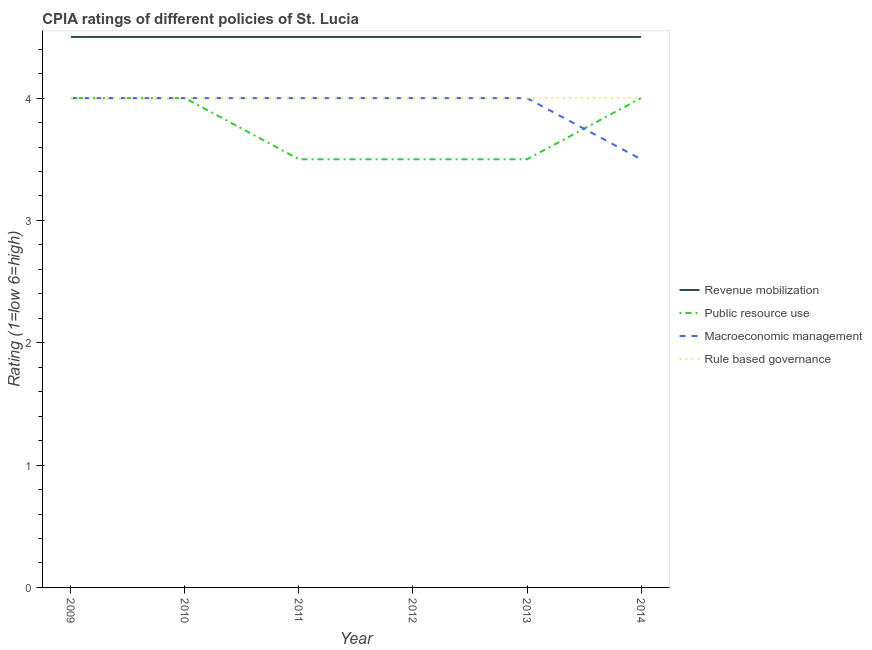Is the number of lines equal to the number of legend labels?
Offer a very short reply. Yes. What is the cpia rating of public resource use in 2011?
Provide a short and direct response. 3.5. Across all years, what is the maximum cpia rating of rule based governance?
Offer a very short reply. 4. Across all years, what is the minimum cpia rating of macroeconomic management?
Your answer should be compact. 3.5. What is the difference between the cpia rating of rule based governance in 2010 and that in 2014?
Offer a terse response. 0. What is the difference between the cpia rating of revenue mobilization in 2014 and the cpia rating of rule based governance in 2012?
Your response must be concise. 0.5. In the year 2011, what is the difference between the cpia rating of macroeconomic management and cpia rating of revenue mobilization?
Provide a succinct answer. -0.5. Is the difference between the cpia rating of macroeconomic management in 2010 and 2012 greater than the difference between the cpia rating of revenue mobilization in 2010 and 2012?
Keep it short and to the point. No. What is the difference between the highest and the lowest cpia rating of revenue mobilization?
Make the answer very short. 0. In how many years, is the cpia rating of rule based governance greater than the average cpia rating of rule based governance taken over all years?
Your response must be concise. 0. Is the sum of the cpia rating of rule based governance in 2009 and 2010 greater than the maximum cpia rating of revenue mobilization across all years?
Give a very brief answer. Yes. Does the cpia rating of revenue mobilization monotonically increase over the years?
Your answer should be very brief. No. Is the cpia rating of public resource use strictly greater than the cpia rating of macroeconomic management over the years?
Provide a succinct answer. No. How many years are there in the graph?
Provide a succinct answer. 6. What is the difference between two consecutive major ticks on the Y-axis?
Your answer should be very brief. 1. Where does the legend appear in the graph?
Your answer should be compact. Center right. How are the legend labels stacked?
Make the answer very short. Vertical. What is the title of the graph?
Ensure brevity in your answer.  CPIA ratings of different policies of St. Lucia. What is the label or title of the Y-axis?
Offer a terse response. Rating (1=low 6=high). What is the Rating (1=low 6=high) in Macroeconomic management in 2009?
Provide a succinct answer. 4. What is the Rating (1=low 6=high) in Revenue mobilization in 2010?
Your answer should be compact. 4.5. What is the Rating (1=low 6=high) of Public resource use in 2010?
Give a very brief answer. 4. What is the Rating (1=low 6=high) in Macroeconomic management in 2010?
Provide a short and direct response. 4. What is the Rating (1=low 6=high) of Rule based governance in 2010?
Offer a terse response. 4. What is the Rating (1=low 6=high) in Rule based governance in 2011?
Your response must be concise. 4. What is the Rating (1=low 6=high) in Revenue mobilization in 2012?
Make the answer very short. 4.5. What is the Rating (1=low 6=high) of Public resource use in 2012?
Make the answer very short. 3.5. What is the Rating (1=low 6=high) of Rule based governance in 2012?
Your answer should be compact. 4. What is the Rating (1=low 6=high) in Public resource use in 2013?
Offer a terse response. 3.5. What is the Rating (1=low 6=high) in Macroeconomic management in 2014?
Provide a succinct answer. 3.5. What is the Rating (1=low 6=high) in Rule based governance in 2014?
Offer a terse response. 4. Across all years, what is the maximum Rating (1=low 6=high) of Revenue mobilization?
Your response must be concise. 4.5. Across all years, what is the maximum Rating (1=low 6=high) of Public resource use?
Keep it short and to the point. 4. Across all years, what is the maximum Rating (1=low 6=high) in Rule based governance?
Keep it short and to the point. 4. Across all years, what is the minimum Rating (1=low 6=high) in Revenue mobilization?
Provide a succinct answer. 4.5. Across all years, what is the minimum Rating (1=low 6=high) of Public resource use?
Make the answer very short. 3.5. Across all years, what is the minimum Rating (1=low 6=high) in Macroeconomic management?
Provide a succinct answer. 3.5. What is the total Rating (1=low 6=high) of Revenue mobilization in the graph?
Provide a short and direct response. 27. What is the total Rating (1=low 6=high) in Public resource use in the graph?
Keep it short and to the point. 22.5. What is the total Rating (1=low 6=high) of Macroeconomic management in the graph?
Offer a very short reply. 23.5. What is the difference between the Rating (1=low 6=high) of Revenue mobilization in 2009 and that in 2010?
Provide a succinct answer. 0. What is the difference between the Rating (1=low 6=high) in Public resource use in 2009 and that in 2010?
Ensure brevity in your answer.  0. What is the difference between the Rating (1=low 6=high) of Rule based governance in 2009 and that in 2010?
Offer a terse response. 0. What is the difference between the Rating (1=low 6=high) in Revenue mobilization in 2009 and that in 2011?
Your response must be concise. 0. What is the difference between the Rating (1=low 6=high) of Revenue mobilization in 2009 and that in 2012?
Offer a terse response. 0. What is the difference between the Rating (1=low 6=high) in Revenue mobilization in 2009 and that in 2013?
Provide a short and direct response. 0. What is the difference between the Rating (1=low 6=high) in Public resource use in 2009 and that in 2013?
Your response must be concise. 0.5. What is the difference between the Rating (1=low 6=high) of Macroeconomic management in 2009 and that in 2013?
Keep it short and to the point. 0. What is the difference between the Rating (1=low 6=high) in Revenue mobilization in 2009 and that in 2014?
Provide a short and direct response. 0. What is the difference between the Rating (1=low 6=high) in Public resource use in 2009 and that in 2014?
Your answer should be very brief. 0. What is the difference between the Rating (1=low 6=high) of Rule based governance in 2009 and that in 2014?
Provide a short and direct response. 0. What is the difference between the Rating (1=low 6=high) of Public resource use in 2010 and that in 2011?
Ensure brevity in your answer.  0.5. What is the difference between the Rating (1=low 6=high) of Macroeconomic management in 2010 and that in 2011?
Keep it short and to the point. 0. What is the difference between the Rating (1=low 6=high) of Public resource use in 2010 and that in 2014?
Your response must be concise. 0. What is the difference between the Rating (1=low 6=high) in Macroeconomic management in 2010 and that in 2014?
Your answer should be very brief. 0.5. What is the difference between the Rating (1=low 6=high) of Revenue mobilization in 2011 and that in 2012?
Offer a terse response. 0. What is the difference between the Rating (1=low 6=high) of Revenue mobilization in 2011 and that in 2013?
Make the answer very short. 0. What is the difference between the Rating (1=low 6=high) of Macroeconomic management in 2011 and that in 2013?
Give a very brief answer. 0. What is the difference between the Rating (1=low 6=high) in Revenue mobilization in 2011 and that in 2014?
Give a very brief answer. 0. What is the difference between the Rating (1=low 6=high) in Public resource use in 2011 and that in 2014?
Offer a very short reply. -0.5. What is the difference between the Rating (1=low 6=high) of Macroeconomic management in 2011 and that in 2014?
Give a very brief answer. 0.5. What is the difference between the Rating (1=low 6=high) of Revenue mobilization in 2012 and that in 2013?
Provide a short and direct response. 0. What is the difference between the Rating (1=low 6=high) in Rule based governance in 2012 and that in 2013?
Your response must be concise. 0. What is the difference between the Rating (1=low 6=high) of Revenue mobilization in 2012 and that in 2014?
Your response must be concise. 0. What is the difference between the Rating (1=low 6=high) of Public resource use in 2013 and that in 2014?
Ensure brevity in your answer.  -0.5. What is the difference between the Rating (1=low 6=high) in Rule based governance in 2013 and that in 2014?
Provide a short and direct response. 0. What is the difference between the Rating (1=low 6=high) in Revenue mobilization in 2009 and the Rating (1=low 6=high) in Macroeconomic management in 2010?
Offer a very short reply. 0.5. What is the difference between the Rating (1=low 6=high) of Public resource use in 2009 and the Rating (1=low 6=high) of Rule based governance in 2010?
Give a very brief answer. 0. What is the difference between the Rating (1=low 6=high) of Macroeconomic management in 2009 and the Rating (1=low 6=high) of Rule based governance in 2010?
Your answer should be very brief. 0. What is the difference between the Rating (1=low 6=high) of Revenue mobilization in 2009 and the Rating (1=low 6=high) of Public resource use in 2011?
Keep it short and to the point. 1. What is the difference between the Rating (1=low 6=high) of Public resource use in 2009 and the Rating (1=low 6=high) of Rule based governance in 2011?
Make the answer very short. 0. What is the difference between the Rating (1=low 6=high) of Revenue mobilization in 2009 and the Rating (1=low 6=high) of Macroeconomic management in 2012?
Your answer should be compact. 0.5. What is the difference between the Rating (1=low 6=high) in Public resource use in 2009 and the Rating (1=low 6=high) in Macroeconomic management in 2012?
Keep it short and to the point. 0. What is the difference between the Rating (1=low 6=high) of Macroeconomic management in 2009 and the Rating (1=low 6=high) of Rule based governance in 2012?
Your response must be concise. 0. What is the difference between the Rating (1=low 6=high) in Revenue mobilization in 2009 and the Rating (1=low 6=high) in Public resource use in 2013?
Ensure brevity in your answer.  1. What is the difference between the Rating (1=low 6=high) of Revenue mobilization in 2009 and the Rating (1=low 6=high) of Rule based governance in 2013?
Keep it short and to the point. 0.5. What is the difference between the Rating (1=low 6=high) of Macroeconomic management in 2009 and the Rating (1=low 6=high) of Rule based governance in 2013?
Ensure brevity in your answer.  0. What is the difference between the Rating (1=low 6=high) of Public resource use in 2009 and the Rating (1=low 6=high) of Macroeconomic management in 2014?
Make the answer very short. 0.5. What is the difference between the Rating (1=low 6=high) in Revenue mobilization in 2010 and the Rating (1=low 6=high) in Public resource use in 2011?
Your answer should be very brief. 1. What is the difference between the Rating (1=low 6=high) in Revenue mobilization in 2010 and the Rating (1=low 6=high) in Macroeconomic management in 2011?
Ensure brevity in your answer.  0.5. What is the difference between the Rating (1=low 6=high) of Revenue mobilization in 2010 and the Rating (1=low 6=high) of Rule based governance in 2011?
Ensure brevity in your answer.  0.5. What is the difference between the Rating (1=low 6=high) of Public resource use in 2010 and the Rating (1=low 6=high) of Rule based governance in 2011?
Keep it short and to the point. 0. What is the difference between the Rating (1=low 6=high) of Macroeconomic management in 2010 and the Rating (1=low 6=high) of Rule based governance in 2011?
Make the answer very short. 0. What is the difference between the Rating (1=low 6=high) in Public resource use in 2010 and the Rating (1=low 6=high) in Macroeconomic management in 2012?
Offer a terse response. 0. What is the difference between the Rating (1=low 6=high) of Revenue mobilization in 2010 and the Rating (1=low 6=high) of Macroeconomic management in 2013?
Give a very brief answer. 0.5. What is the difference between the Rating (1=low 6=high) in Macroeconomic management in 2010 and the Rating (1=low 6=high) in Rule based governance in 2013?
Ensure brevity in your answer.  0. What is the difference between the Rating (1=low 6=high) of Revenue mobilization in 2010 and the Rating (1=low 6=high) of Macroeconomic management in 2014?
Make the answer very short. 1. What is the difference between the Rating (1=low 6=high) of Revenue mobilization in 2010 and the Rating (1=low 6=high) of Rule based governance in 2014?
Provide a succinct answer. 0.5. What is the difference between the Rating (1=low 6=high) of Public resource use in 2010 and the Rating (1=low 6=high) of Macroeconomic management in 2014?
Provide a succinct answer. 0.5. What is the difference between the Rating (1=low 6=high) in Revenue mobilization in 2011 and the Rating (1=low 6=high) in Public resource use in 2012?
Offer a very short reply. 1. What is the difference between the Rating (1=low 6=high) of Public resource use in 2011 and the Rating (1=low 6=high) of Macroeconomic management in 2012?
Provide a short and direct response. -0.5. What is the difference between the Rating (1=low 6=high) of Revenue mobilization in 2011 and the Rating (1=low 6=high) of Public resource use in 2013?
Offer a terse response. 1. What is the difference between the Rating (1=low 6=high) in Revenue mobilization in 2011 and the Rating (1=low 6=high) in Macroeconomic management in 2013?
Your answer should be compact. 0.5. What is the difference between the Rating (1=low 6=high) in Revenue mobilization in 2011 and the Rating (1=low 6=high) in Rule based governance in 2013?
Ensure brevity in your answer.  0.5. What is the difference between the Rating (1=low 6=high) in Public resource use in 2011 and the Rating (1=low 6=high) in Rule based governance in 2013?
Give a very brief answer. -0.5. What is the difference between the Rating (1=low 6=high) in Revenue mobilization in 2011 and the Rating (1=low 6=high) in Macroeconomic management in 2014?
Your response must be concise. 1. What is the difference between the Rating (1=low 6=high) in Revenue mobilization in 2011 and the Rating (1=low 6=high) in Rule based governance in 2014?
Offer a terse response. 0.5. What is the difference between the Rating (1=low 6=high) of Macroeconomic management in 2011 and the Rating (1=low 6=high) of Rule based governance in 2014?
Your response must be concise. 0. What is the difference between the Rating (1=low 6=high) in Public resource use in 2012 and the Rating (1=low 6=high) in Macroeconomic management in 2013?
Offer a very short reply. -0.5. What is the difference between the Rating (1=low 6=high) of Revenue mobilization in 2012 and the Rating (1=low 6=high) of Public resource use in 2014?
Offer a terse response. 0.5. What is the difference between the Rating (1=low 6=high) of Revenue mobilization in 2012 and the Rating (1=low 6=high) of Macroeconomic management in 2014?
Provide a succinct answer. 1. What is the difference between the Rating (1=low 6=high) in Revenue mobilization in 2012 and the Rating (1=low 6=high) in Rule based governance in 2014?
Offer a very short reply. 0.5. What is the difference between the Rating (1=low 6=high) of Public resource use in 2012 and the Rating (1=low 6=high) of Macroeconomic management in 2014?
Ensure brevity in your answer.  0. What is the difference between the Rating (1=low 6=high) of Revenue mobilization in 2013 and the Rating (1=low 6=high) of Macroeconomic management in 2014?
Provide a short and direct response. 1. What is the difference between the Rating (1=low 6=high) in Revenue mobilization in 2013 and the Rating (1=low 6=high) in Rule based governance in 2014?
Your answer should be very brief. 0.5. What is the difference between the Rating (1=low 6=high) of Macroeconomic management in 2013 and the Rating (1=low 6=high) of Rule based governance in 2014?
Give a very brief answer. 0. What is the average Rating (1=low 6=high) in Revenue mobilization per year?
Offer a very short reply. 4.5. What is the average Rating (1=low 6=high) of Public resource use per year?
Keep it short and to the point. 3.75. What is the average Rating (1=low 6=high) of Macroeconomic management per year?
Your response must be concise. 3.92. What is the average Rating (1=low 6=high) in Rule based governance per year?
Your response must be concise. 4. In the year 2009, what is the difference between the Rating (1=low 6=high) of Revenue mobilization and Rating (1=low 6=high) of Public resource use?
Give a very brief answer. 0.5. In the year 2009, what is the difference between the Rating (1=low 6=high) in Revenue mobilization and Rating (1=low 6=high) in Rule based governance?
Ensure brevity in your answer.  0.5. In the year 2009, what is the difference between the Rating (1=low 6=high) in Public resource use and Rating (1=low 6=high) in Macroeconomic management?
Your answer should be very brief. 0. In the year 2009, what is the difference between the Rating (1=low 6=high) in Public resource use and Rating (1=low 6=high) in Rule based governance?
Give a very brief answer. 0. In the year 2009, what is the difference between the Rating (1=low 6=high) in Macroeconomic management and Rating (1=low 6=high) in Rule based governance?
Offer a terse response. 0. In the year 2010, what is the difference between the Rating (1=low 6=high) of Revenue mobilization and Rating (1=low 6=high) of Public resource use?
Keep it short and to the point. 0.5. In the year 2010, what is the difference between the Rating (1=low 6=high) of Revenue mobilization and Rating (1=low 6=high) of Macroeconomic management?
Your answer should be very brief. 0.5. In the year 2010, what is the difference between the Rating (1=low 6=high) in Public resource use and Rating (1=low 6=high) in Macroeconomic management?
Keep it short and to the point. 0. In the year 2010, what is the difference between the Rating (1=low 6=high) of Macroeconomic management and Rating (1=low 6=high) of Rule based governance?
Make the answer very short. 0. In the year 2011, what is the difference between the Rating (1=low 6=high) in Revenue mobilization and Rating (1=low 6=high) in Rule based governance?
Provide a succinct answer. 0.5. In the year 2011, what is the difference between the Rating (1=low 6=high) in Public resource use and Rating (1=low 6=high) in Rule based governance?
Your answer should be compact. -0.5. In the year 2012, what is the difference between the Rating (1=low 6=high) in Revenue mobilization and Rating (1=low 6=high) in Macroeconomic management?
Your answer should be very brief. 0.5. In the year 2012, what is the difference between the Rating (1=low 6=high) of Revenue mobilization and Rating (1=low 6=high) of Rule based governance?
Offer a very short reply. 0.5. In the year 2012, what is the difference between the Rating (1=low 6=high) of Public resource use and Rating (1=low 6=high) of Macroeconomic management?
Offer a very short reply. -0.5. In the year 2012, what is the difference between the Rating (1=low 6=high) in Macroeconomic management and Rating (1=low 6=high) in Rule based governance?
Provide a short and direct response. 0. In the year 2013, what is the difference between the Rating (1=low 6=high) in Revenue mobilization and Rating (1=low 6=high) in Public resource use?
Provide a succinct answer. 1. In the year 2013, what is the difference between the Rating (1=low 6=high) in Public resource use and Rating (1=low 6=high) in Macroeconomic management?
Provide a succinct answer. -0.5. In the year 2013, what is the difference between the Rating (1=low 6=high) of Macroeconomic management and Rating (1=low 6=high) of Rule based governance?
Offer a very short reply. 0. In the year 2014, what is the difference between the Rating (1=low 6=high) of Revenue mobilization and Rating (1=low 6=high) of Macroeconomic management?
Make the answer very short. 1. In the year 2014, what is the difference between the Rating (1=low 6=high) of Revenue mobilization and Rating (1=low 6=high) of Rule based governance?
Your answer should be very brief. 0.5. What is the ratio of the Rating (1=low 6=high) of Public resource use in 2009 to that in 2010?
Give a very brief answer. 1. What is the ratio of the Rating (1=low 6=high) of Rule based governance in 2009 to that in 2010?
Provide a short and direct response. 1. What is the ratio of the Rating (1=low 6=high) of Revenue mobilization in 2009 to that in 2011?
Keep it short and to the point. 1. What is the ratio of the Rating (1=low 6=high) in Public resource use in 2009 to that in 2011?
Your response must be concise. 1.14. What is the ratio of the Rating (1=low 6=high) in Rule based governance in 2009 to that in 2011?
Offer a very short reply. 1. What is the ratio of the Rating (1=low 6=high) of Revenue mobilization in 2009 to that in 2012?
Ensure brevity in your answer.  1. What is the ratio of the Rating (1=low 6=high) in Rule based governance in 2009 to that in 2012?
Your answer should be very brief. 1. What is the ratio of the Rating (1=low 6=high) of Revenue mobilization in 2009 to that in 2013?
Offer a terse response. 1. What is the ratio of the Rating (1=low 6=high) of Public resource use in 2009 to that in 2013?
Provide a short and direct response. 1.14. What is the ratio of the Rating (1=low 6=high) in Public resource use in 2009 to that in 2014?
Offer a very short reply. 1. What is the ratio of the Rating (1=low 6=high) of Rule based governance in 2009 to that in 2014?
Ensure brevity in your answer.  1. What is the ratio of the Rating (1=low 6=high) in Public resource use in 2010 to that in 2011?
Make the answer very short. 1.14. What is the ratio of the Rating (1=low 6=high) of Macroeconomic management in 2010 to that in 2012?
Your answer should be compact. 1. What is the ratio of the Rating (1=low 6=high) of Rule based governance in 2010 to that in 2012?
Your answer should be very brief. 1. What is the ratio of the Rating (1=low 6=high) in Macroeconomic management in 2010 to that in 2014?
Offer a terse response. 1.14. What is the ratio of the Rating (1=low 6=high) of Rule based governance in 2010 to that in 2014?
Provide a succinct answer. 1. What is the ratio of the Rating (1=low 6=high) in Revenue mobilization in 2011 to that in 2012?
Offer a very short reply. 1. What is the ratio of the Rating (1=low 6=high) in Macroeconomic management in 2011 to that in 2012?
Provide a short and direct response. 1. What is the ratio of the Rating (1=low 6=high) of Rule based governance in 2011 to that in 2012?
Ensure brevity in your answer.  1. What is the ratio of the Rating (1=low 6=high) of Revenue mobilization in 2011 to that in 2013?
Provide a short and direct response. 1. What is the ratio of the Rating (1=low 6=high) of Public resource use in 2011 to that in 2013?
Provide a succinct answer. 1. What is the ratio of the Rating (1=low 6=high) in Revenue mobilization in 2012 to that in 2013?
Keep it short and to the point. 1. What is the ratio of the Rating (1=low 6=high) in Public resource use in 2012 to that in 2013?
Give a very brief answer. 1. What is the ratio of the Rating (1=low 6=high) in Rule based governance in 2012 to that in 2013?
Offer a terse response. 1. What is the ratio of the Rating (1=low 6=high) in Revenue mobilization in 2012 to that in 2014?
Keep it short and to the point. 1. What is the ratio of the Rating (1=low 6=high) in Public resource use in 2012 to that in 2014?
Keep it short and to the point. 0.88. What is the ratio of the Rating (1=low 6=high) of Revenue mobilization in 2013 to that in 2014?
Give a very brief answer. 1. What is the ratio of the Rating (1=low 6=high) of Public resource use in 2013 to that in 2014?
Provide a succinct answer. 0.88. What is the ratio of the Rating (1=low 6=high) in Macroeconomic management in 2013 to that in 2014?
Offer a terse response. 1.14. What is the ratio of the Rating (1=low 6=high) in Rule based governance in 2013 to that in 2014?
Your response must be concise. 1. What is the difference between the highest and the second highest Rating (1=low 6=high) of Rule based governance?
Ensure brevity in your answer.  0. What is the difference between the highest and the lowest Rating (1=low 6=high) in Revenue mobilization?
Keep it short and to the point. 0. 